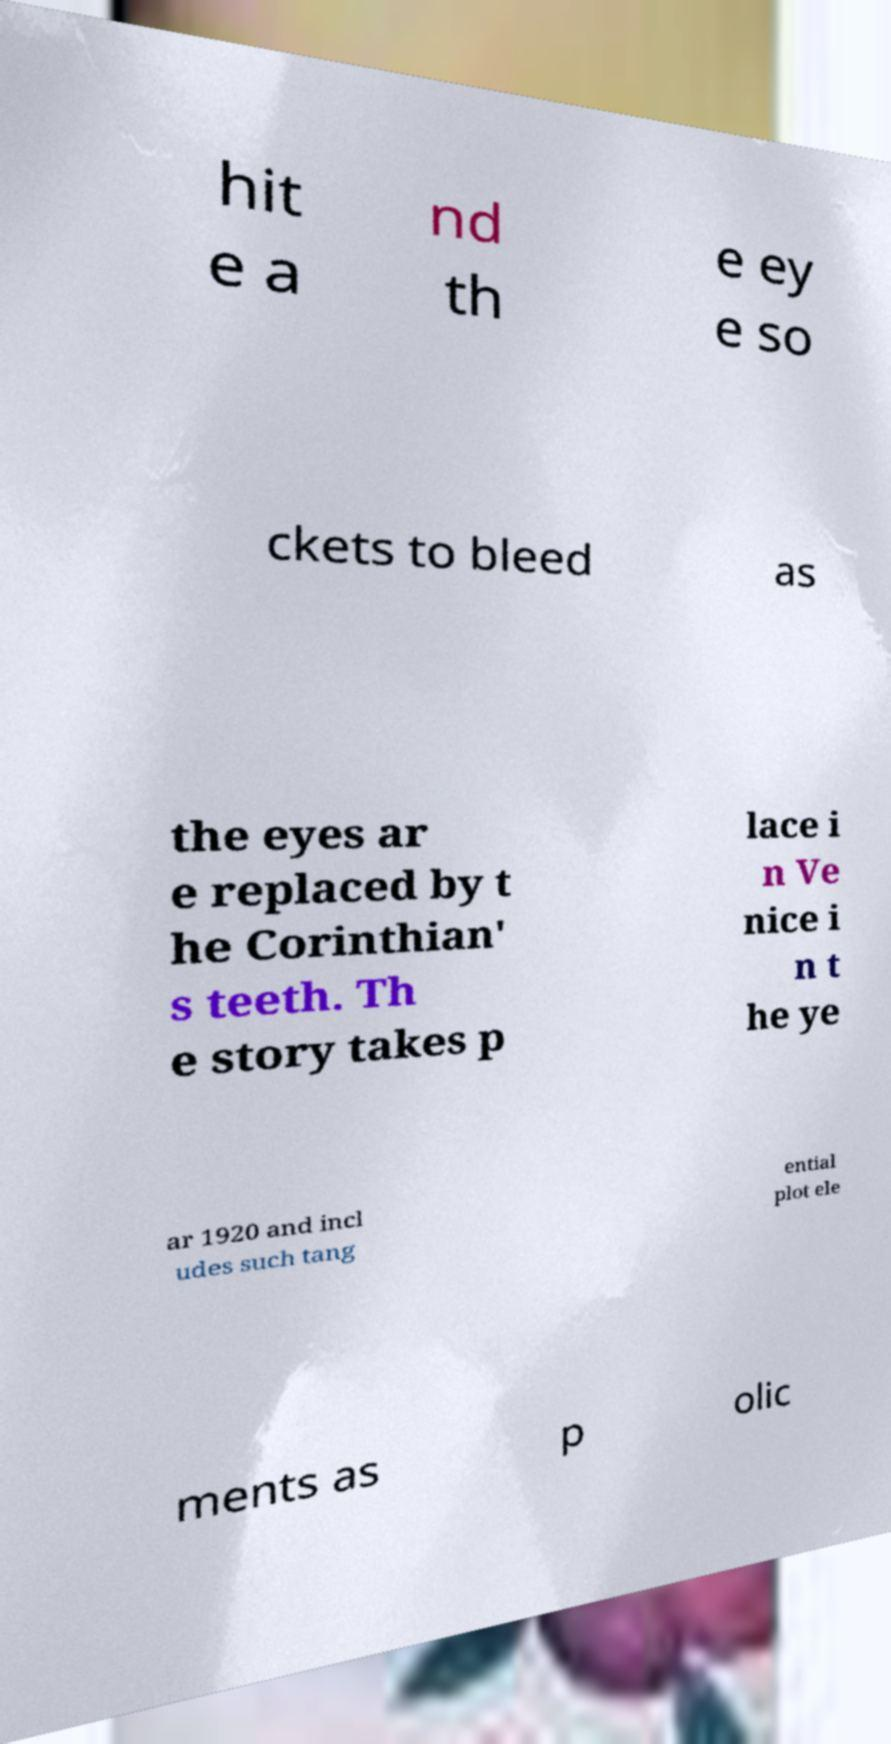Could you assist in decoding the text presented in this image and type it out clearly? hit e a nd th e ey e so ckets to bleed as the eyes ar e replaced by t he Corinthian' s teeth. Th e story takes p lace i n Ve nice i n t he ye ar 1920 and incl udes such tang ential plot ele ments as p olic 